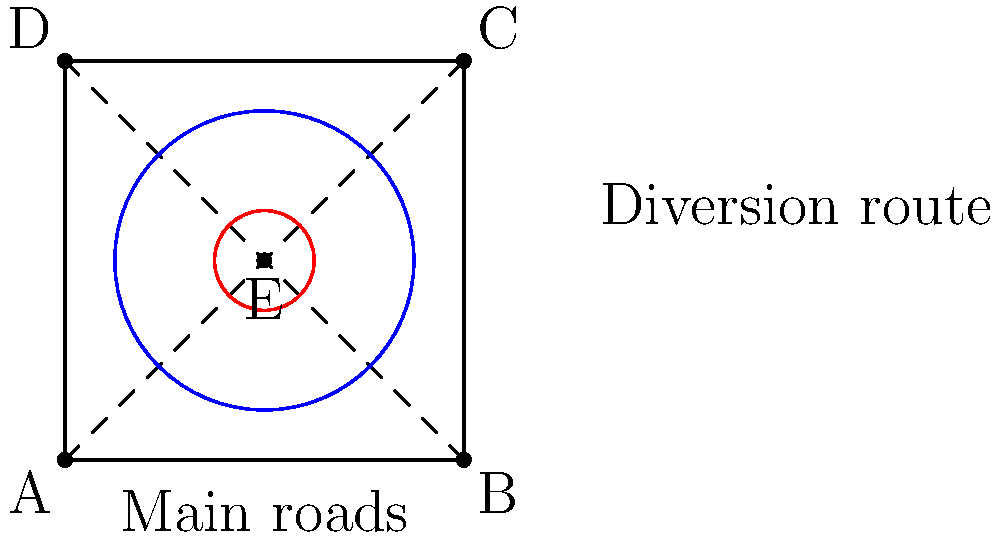A busy intersection in your district is experiencing high traffic congestion. You propose a circular traffic diversion scheme around the intersection, as shown in the diagram. The outer circle represents the diversion route, while the inner circle represents the central island. If the diversion route has a radius of 1.5 units and the central island has a radius of 0.5 units, what is the area of the drivable portion of the diversion scheme? Express your answer in terms of π. To find the area of the drivable portion of the diversion scheme, we need to:

1. Calculate the area of the outer circle (diversion route):
   $A_{outer} = \pi r^2 = \pi (1.5)^2 = 2.25\pi$

2. Calculate the area of the inner circle (central island):
   $A_{inner} = \pi r^2 = \pi (0.5)^2 = 0.25\pi$

3. Subtract the area of the inner circle from the area of the outer circle:
   $A_{drivable} = A_{outer} - A_{inner}$
   $A_{drivable} = 2.25\pi - 0.25\pi = 2\pi$

The drivable area is the difference between the areas of the outer and inner circles, which represents the circular road that vehicles can use for the diversion.
Answer: $2\pi$ square units 